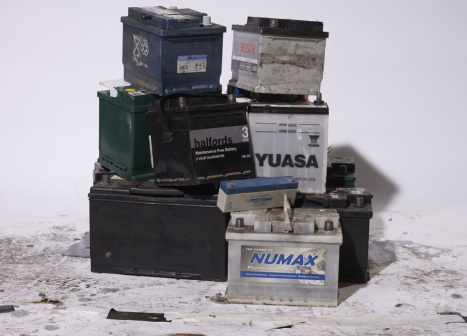Can you explain the history of these batteries? Certainly! Each of these batteries has its own unique history, much like the vehicles they powered. The NUMAX battery once served a robust SUV, enduring countless road trips and family journeys. YUASA lived in a sleek sports car, thrilling with high-speed adventures on the track. Halfords 3, known for dependable performance, spent years in a steadfast family sedan, supporting countless commutes and errands. Now, at the end of their serviceable lives, they find themselves at this collection point, soon to be part of a recycling process where their components can be recovered and reused, continuing their journey in new forms. 